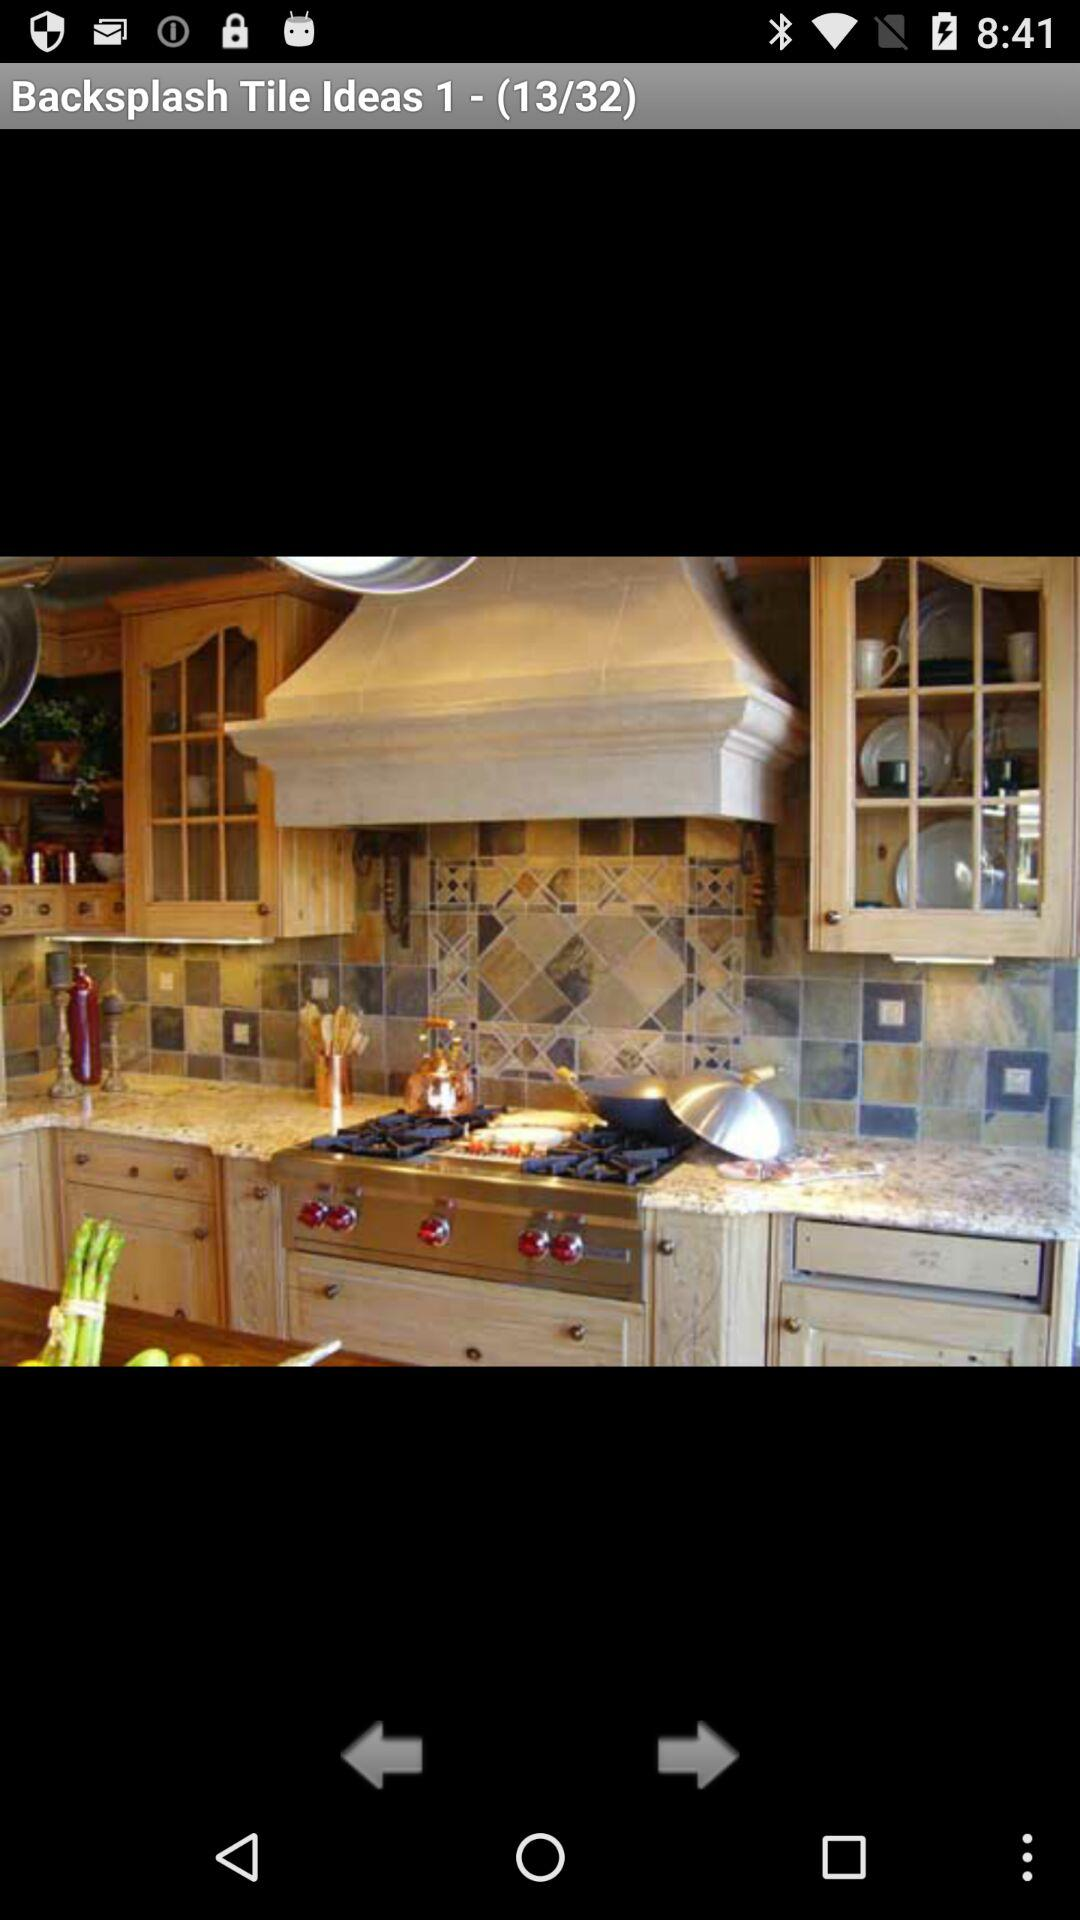What is the total number of images? The total number of pages is 32. 